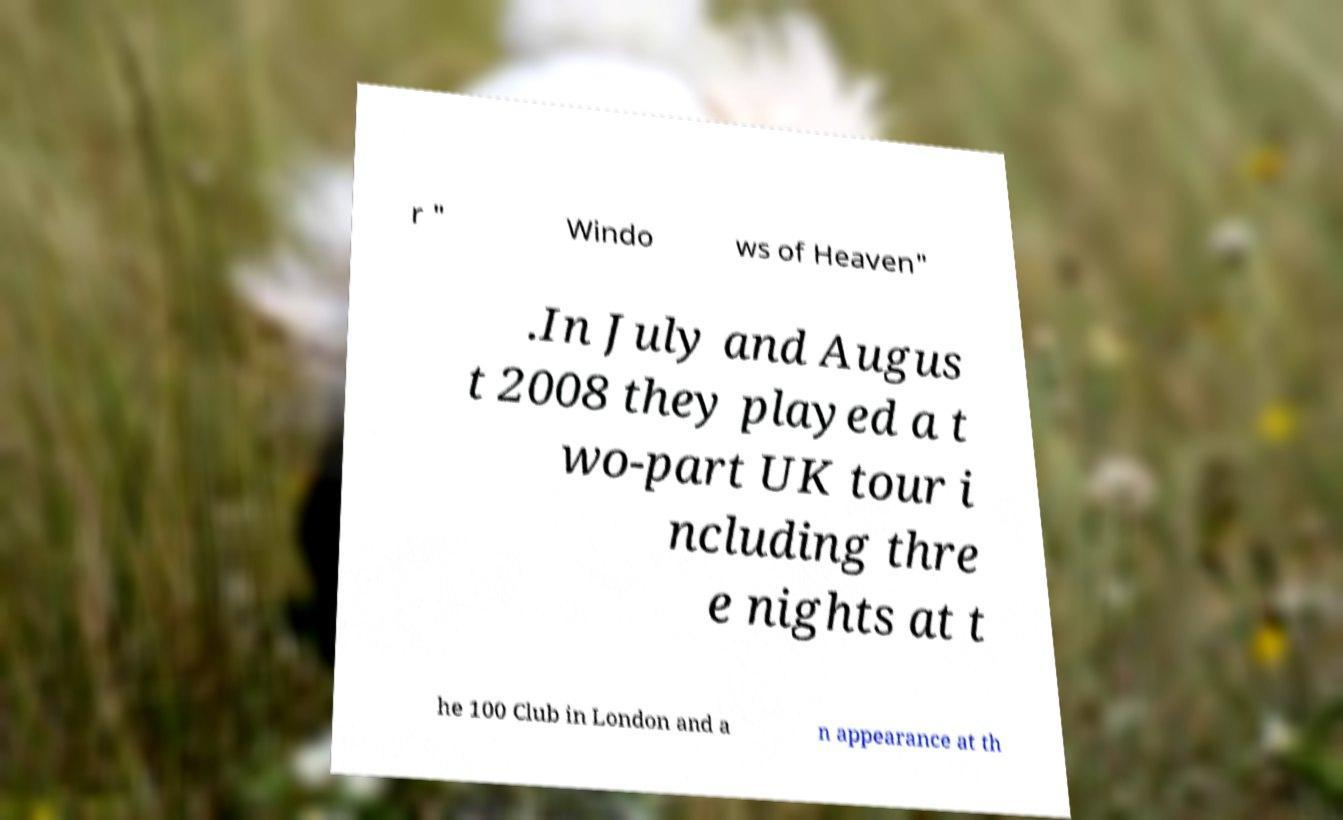Could you assist in decoding the text presented in this image and type it out clearly? r " Windo ws of Heaven" .In July and Augus t 2008 they played a t wo-part UK tour i ncluding thre e nights at t he 100 Club in London and a n appearance at th 